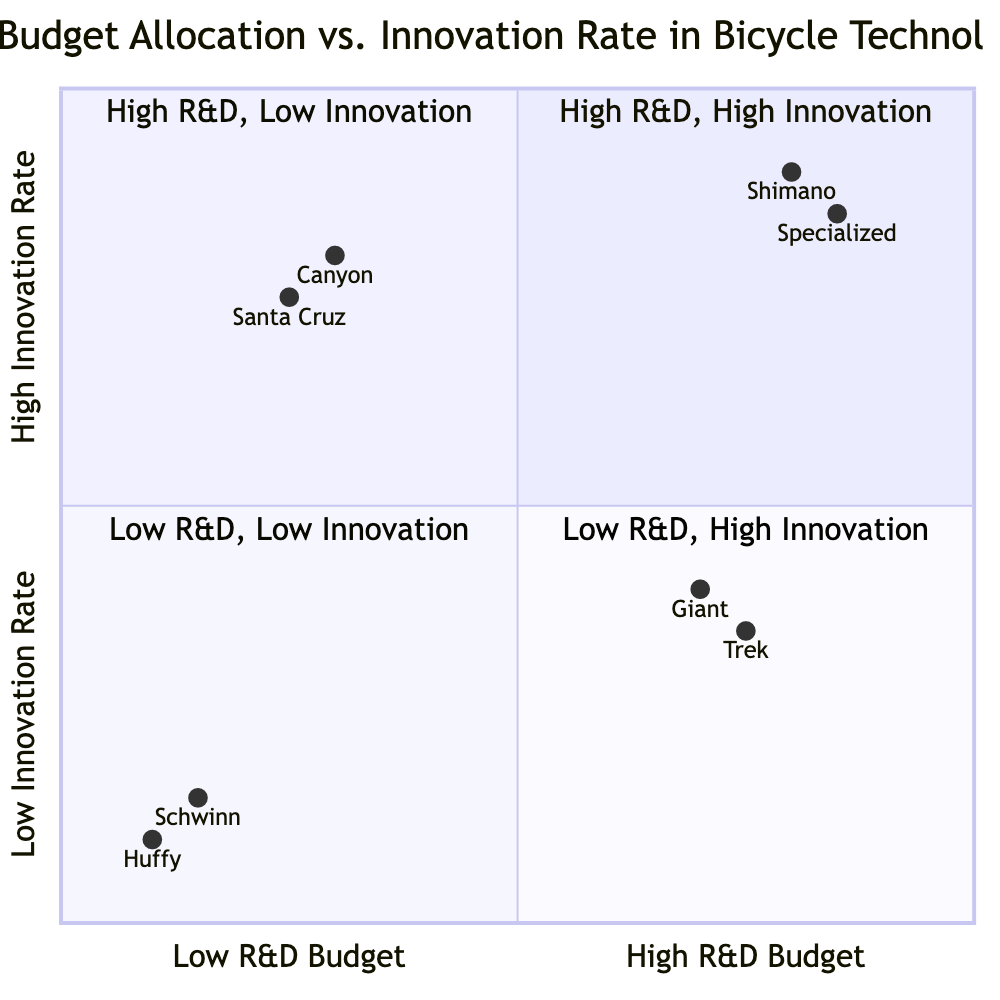What companies are in the High R&D Budget, High Innovation Rate quadrant? The High R&D Budget, High Innovation Rate quadrant includes Shimano and Specialized Bicycle Components, as these companies invest significantly in R&D and achieve a high rate of innovation.
Answer: Shimano, Specialized Bicycle Components What is the innovation rate for Giant Bicycles? Within the quadrant representing High R&D Budget, Low Innovation Rate, Giant Bicycles has an innovation rate of 0.4.
Answer: 0.4 Which company has the lowest R&D budget? In the Low R&D Budget, Low Innovation Rate quadrant, Huffy Bicycles is noted for having the lowest R&D budget, indicated by the coordinates reflecting a low value on the x-axis.
Answer: Huffy Bicycles How many companies are in the Low R&D Budget, High Innovation Rate quadrant? In the Low R&D Budget, High Innovation Rate quadrant, there are two companies, Canyon Bicycles and Santa Cruz Bicycles, which represents a higher innovation rate despite a lower R&D budget.
Answer: 2 What is the relationship between R&D budget and innovation rate for Trek Bicycle Corporation? Trek Bicycle Corporation, located in the High R&D Budget, Low Innovation Rate quadrant, shows a clear relationship—they invest significantly in R&D but their innovation rate is relatively low, as they focus more on existing technologies.
Answer: High R&D, Low Innovation Which company performs better in innovation relative to their R&D spending, Canyon or Giant? Canyon Bicycles performs better in innovation relative to their R&D spending, being in the Low R&D Budget, High Innovation Rate quadrant while Giant Bicycles is in the High R&D Budget, Low Innovation Rate quadrant.
Answer: Canyon Bicycles What quadrant contains companies that typically focus on classic designs? The Low R&D Budget, Low Innovation Rate quadrant contains companies like Schwinn, which focus primarily on classic designs and essential functions rather than high innovation.
Answer: Low R&D Budget, Low Innovation Rate Which company has a higher innovation rate, Shimano or Santa Cruz Bicycles? Comparing the innovation rates, Shimano has an innovation rate of 0.9 while Santa Cruz Bicycles has an innovation rate of 0.75; thus, Shimano exhibits a higher innovation rate.
Answer: Shimano 